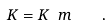<formula> <loc_0><loc_0><loc_500><loc_500>K = K ^ { \ } _ { \ } m \quad .</formula> 